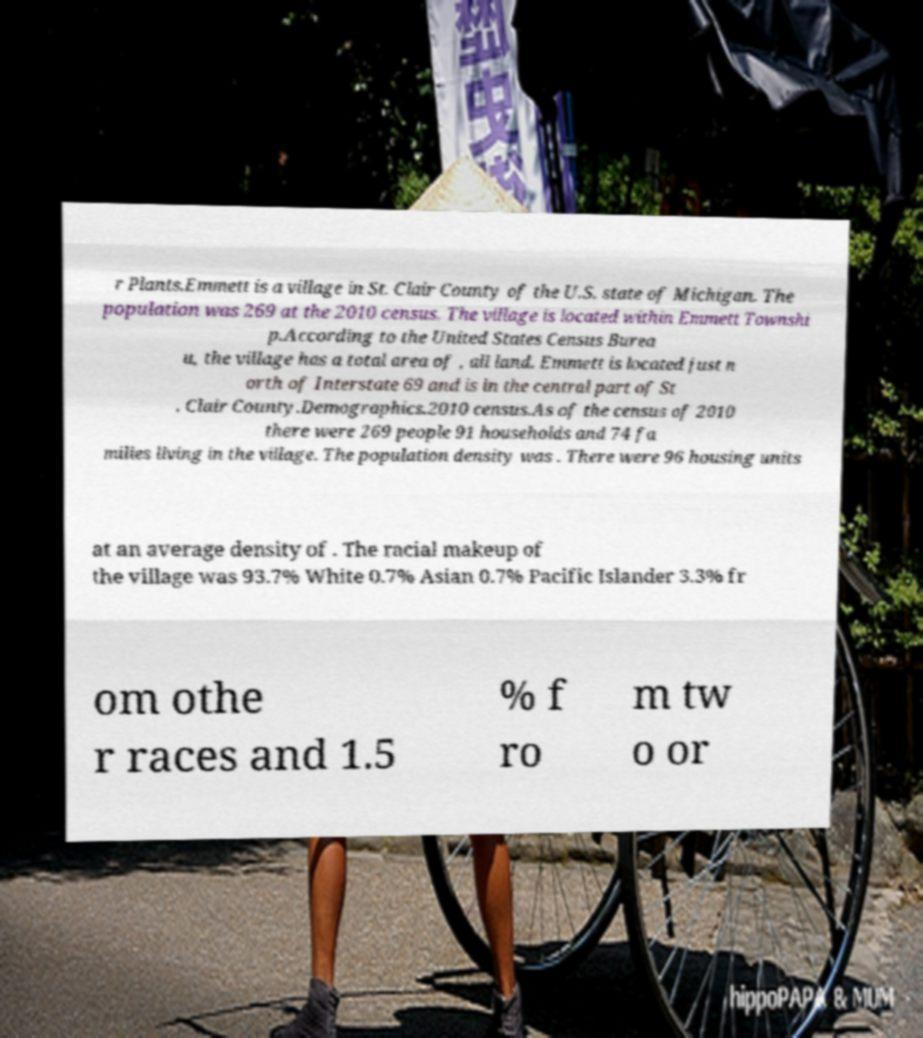What messages or text are displayed in this image? I need them in a readable, typed format. r Plants.Emmett is a village in St. Clair County of the U.S. state of Michigan. The population was 269 at the 2010 census. The village is located within Emmett Townshi p.According to the United States Census Burea u, the village has a total area of , all land. Emmett is located just n orth of Interstate 69 and is in the central part of St . Clair County.Demographics.2010 census.As of the census of 2010 there were 269 people 91 households and 74 fa milies living in the village. The population density was . There were 96 housing units at an average density of . The racial makeup of the village was 93.7% White 0.7% Asian 0.7% Pacific Islander 3.3% fr om othe r races and 1.5 % f ro m tw o or 